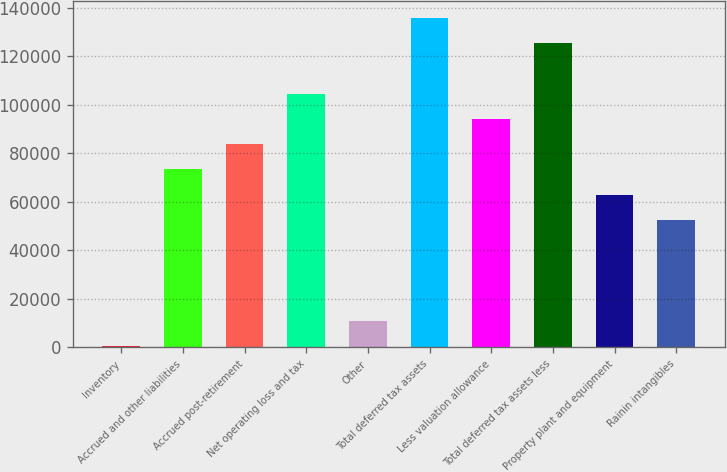<chart> <loc_0><loc_0><loc_500><loc_500><bar_chart><fcel>Inventory<fcel>Accrued and other liabilities<fcel>Accrued post-retirement<fcel>Net operating loss and tax<fcel>Other<fcel>Total deferred tax assets<fcel>Less valuation allowance<fcel>Total deferred tax assets less<fcel>Property plant and equipment<fcel>Rainin intangibles<nl><fcel>522<fcel>73352.1<fcel>83756.4<fcel>104565<fcel>10926.3<fcel>135778<fcel>94160.7<fcel>125374<fcel>62947.8<fcel>52543.5<nl></chart> 